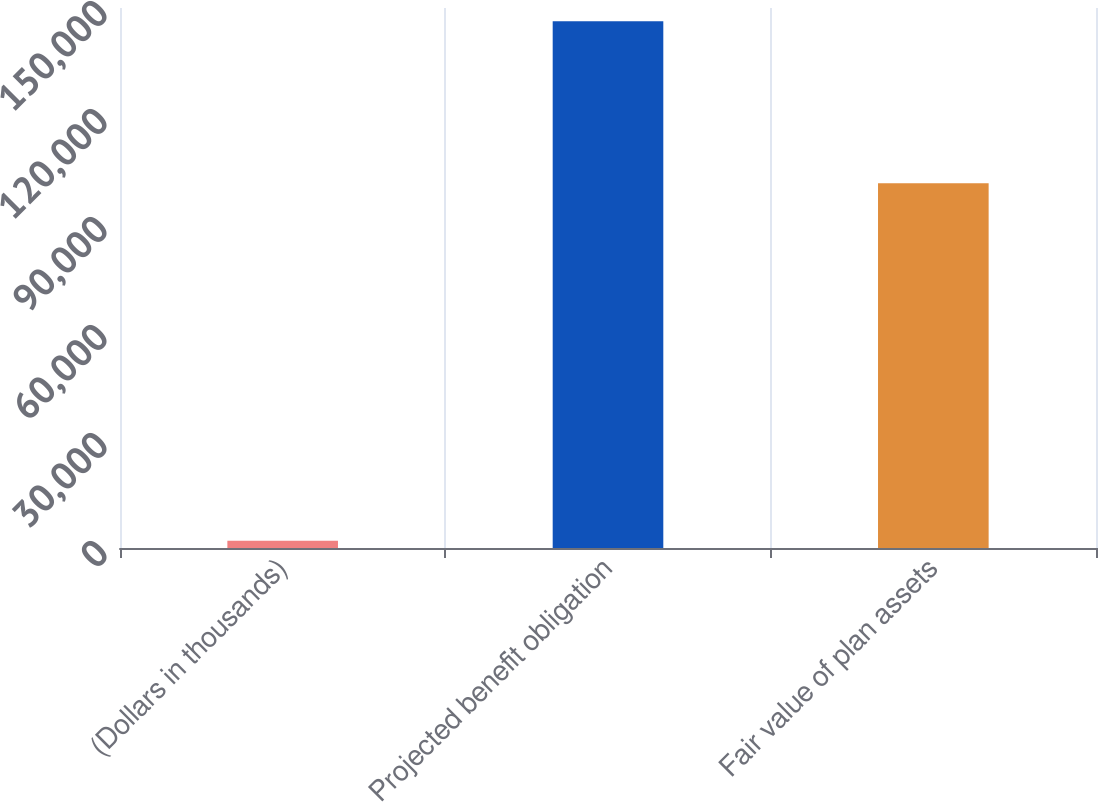Convert chart. <chart><loc_0><loc_0><loc_500><loc_500><bar_chart><fcel>(Dollars in thousands)<fcel>Projected benefit obligation<fcel>Fair value of plan assets<nl><fcel>2011<fcel>146350<fcel>101304<nl></chart> 